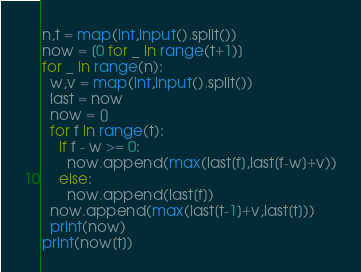<code> <loc_0><loc_0><loc_500><loc_500><_Python_>n,t = map(int,input().split())
now = [0 for _ in range(t+1)]
for _ in range(n):
  w,v = map(int,input().split())
  last = now
  now = []
  for f in range(t):
    if f - w >= 0:
      now.append(max(last[f],last[f-w]+v))
    else:
      now.append(last[f])
  now.append(max(last[t-1]+v,last[t]))
  print(now)
print(now[t])</code> 